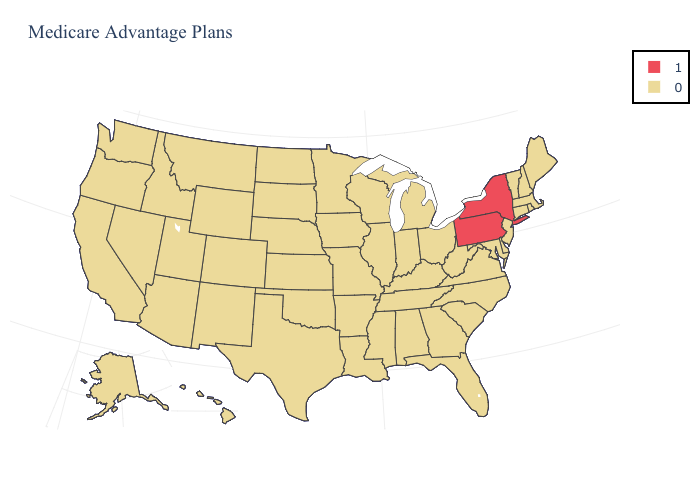Does New York have the highest value in the USA?
Keep it brief. Yes. Name the states that have a value in the range 0?
Keep it brief. Alaska, Alabama, Arkansas, Arizona, California, Colorado, Connecticut, Delaware, Florida, Georgia, Hawaii, Iowa, Idaho, Illinois, Indiana, Kansas, Kentucky, Louisiana, Massachusetts, Maryland, Maine, Michigan, Minnesota, Missouri, Mississippi, Montana, North Carolina, North Dakota, Nebraska, New Hampshire, New Jersey, New Mexico, Nevada, Ohio, Oklahoma, Oregon, Rhode Island, South Carolina, South Dakota, Tennessee, Texas, Utah, Virginia, Vermont, Washington, Wisconsin, West Virginia, Wyoming. Does Washington have a higher value than New Hampshire?
Quick response, please. No. What is the lowest value in the USA?
Keep it brief. 0. Name the states that have a value in the range 1?
Give a very brief answer. New York, Pennsylvania. What is the value of Maine?
Be succinct. 0. Name the states that have a value in the range 1?
Short answer required. New York, Pennsylvania. How many symbols are there in the legend?
Short answer required. 2. Which states hav the highest value in the MidWest?
Give a very brief answer. Iowa, Illinois, Indiana, Kansas, Michigan, Minnesota, Missouri, North Dakota, Nebraska, Ohio, South Dakota, Wisconsin. What is the value of Maryland?
Answer briefly. 0. Name the states that have a value in the range 0?
Short answer required. Alaska, Alabama, Arkansas, Arizona, California, Colorado, Connecticut, Delaware, Florida, Georgia, Hawaii, Iowa, Idaho, Illinois, Indiana, Kansas, Kentucky, Louisiana, Massachusetts, Maryland, Maine, Michigan, Minnesota, Missouri, Mississippi, Montana, North Carolina, North Dakota, Nebraska, New Hampshire, New Jersey, New Mexico, Nevada, Ohio, Oklahoma, Oregon, Rhode Island, South Carolina, South Dakota, Tennessee, Texas, Utah, Virginia, Vermont, Washington, Wisconsin, West Virginia, Wyoming. What is the value of Wisconsin?
Be succinct. 0. 